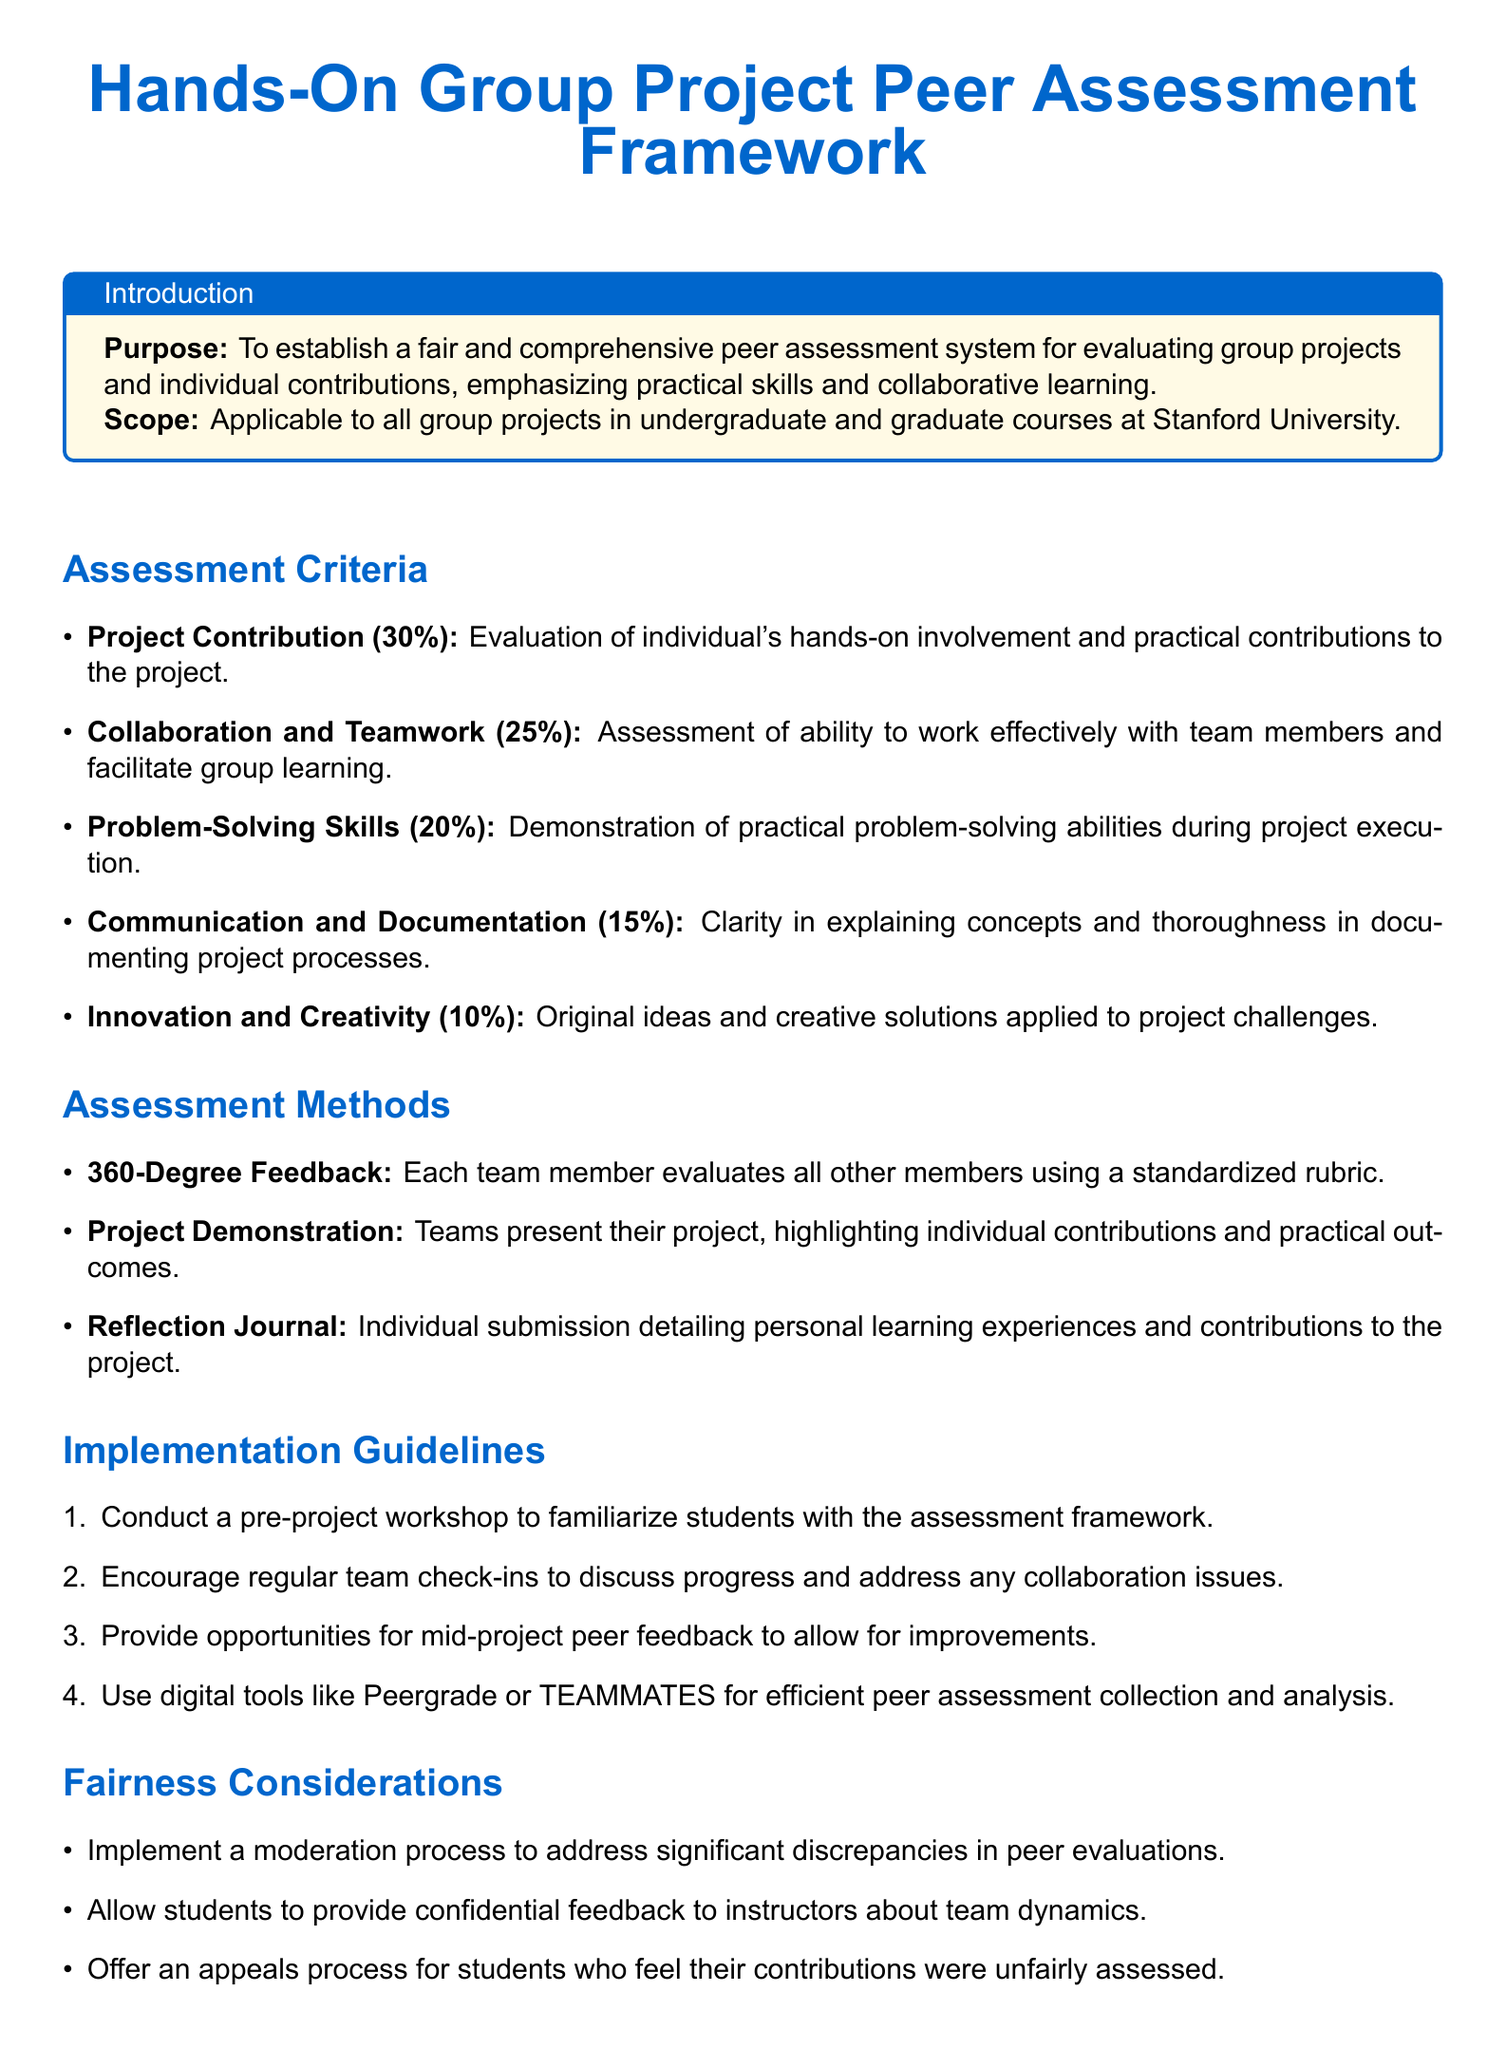What is the purpose of the document? The purpose outlines the goal of establishing a fair peer assessment system for evaluating group projects and individual contributions.
Answer: To establish a fair and comprehensive peer assessment system What is the scope of this framework? The scope specifies the applicability of the peer assessment framework to group projects across different courses.
Answer: Applicable to all group projects in undergraduate and graduate courses at Stanford University What percentage of the assessment criteria is allocated to Project Contribution? This percentage indicates the weight assigned to evaluating an individual's contributions in the project.
Answer: 30% What method is used for peer feedback collection? The method specifies a digital tool that aids in the peer assessment process.
Answer: Peergrade or TEAMMATES What is one fairness consideration mentioned in the document? This consideration relates to ensuring fairness in student evaluations and addressing discrepancies.
Answer: Implement a moderation process How many assessment criteria are listed in the document? This number reflects the total distinct areas considered for assessing contributions.
Answer: Five What is the weight given to Innovation and Creativity in the assessment criteria? This weight denotes how much importance is placed on original ideas and solutions in the project's evaluation.
Answer: 10% What is required in the Reflection Journal submission? This specifies a type of individual documentation students submit regarding their contributions and learning experiences.
Answer: Personal learning experiences and contributions to the project What is the suggested frequency of team check-ins? This refers to the recommended regularity for teams to discuss their progress and issues collaboratively.
Answer: Regular 